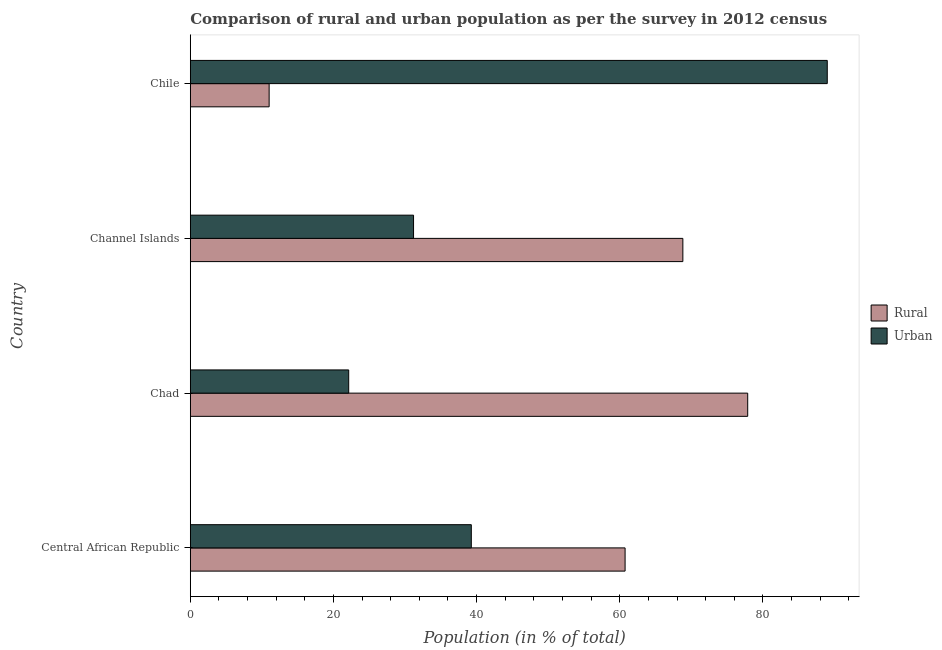How many groups of bars are there?
Your answer should be compact. 4. Are the number of bars on each tick of the Y-axis equal?
Your answer should be very brief. Yes. How many bars are there on the 2nd tick from the bottom?
Your answer should be very brief. 2. What is the label of the 2nd group of bars from the top?
Offer a terse response. Channel Islands. What is the rural population in Chad?
Give a very brief answer. 77.87. Across all countries, what is the maximum urban population?
Make the answer very short. 88.99. Across all countries, what is the minimum urban population?
Your answer should be compact. 22.13. In which country was the urban population maximum?
Your answer should be compact. Chile. In which country was the urban population minimum?
Give a very brief answer. Chad. What is the total urban population in the graph?
Ensure brevity in your answer.  181.56. What is the difference between the urban population in Central African Republic and that in Channel Islands?
Ensure brevity in your answer.  8.07. What is the difference between the rural population in Central African Republic and the urban population in Chile?
Keep it short and to the point. -28.24. What is the average urban population per country?
Provide a short and direct response. 45.39. What is the difference between the rural population and urban population in Central African Republic?
Give a very brief answer. 21.48. In how many countries, is the rural population greater than 60 %?
Give a very brief answer. 3. What is the ratio of the rural population in Central African Republic to that in Chile?
Your answer should be compact. 5.51. Is the urban population in Chad less than that in Chile?
Offer a terse response. Yes. Is the difference between the rural population in Central African Republic and Channel Islands greater than the difference between the urban population in Central African Republic and Channel Islands?
Ensure brevity in your answer.  No. What is the difference between the highest and the second highest urban population?
Offer a very short reply. 49.73. What is the difference between the highest and the lowest rural population?
Provide a succinct answer. 66.86. What does the 2nd bar from the top in Chile represents?
Make the answer very short. Rural. What does the 2nd bar from the bottom in Central African Republic represents?
Offer a terse response. Urban. How many bars are there?
Provide a short and direct response. 8. Does the graph contain any zero values?
Provide a succinct answer. No. How many legend labels are there?
Provide a succinct answer. 2. What is the title of the graph?
Your answer should be very brief. Comparison of rural and urban population as per the survey in 2012 census. What is the label or title of the X-axis?
Keep it short and to the point. Population (in % of total). What is the Population (in % of total) in Rural in Central African Republic?
Provide a short and direct response. 60.74. What is the Population (in % of total) of Urban in Central African Republic?
Offer a very short reply. 39.26. What is the Population (in % of total) in Rural in Chad?
Your response must be concise. 77.87. What is the Population (in % of total) of Urban in Chad?
Provide a succinct answer. 22.13. What is the Population (in % of total) in Rural in Channel Islands?
Provide a short and direct response. 68.81. What is the Population (in % of total) of Urban in Channel Islands?
Provide a succinct answer. 31.19. What is the Population (in % of total) of Rural in Chile?
Make the answer very short. 11.01. What is the Population (in % of total) in Urban in Chile?
Your answer should be compact. 88.99. Across all countries, what is the maximum Population (in % of total) in Rural?
Provide a succinct answer. 77.87. Across all countries, what is the maximum Population (in % of total) of Urban?
Your answer should be compact. 88.99. Across all countries, what is the minimum Population (in % of total) in Rural?
Your answer should be compact. 11.01. Across all countries, what is the minimum Population (in % of total) of Urban?
Make the answer very short. 22.13. What is the total Population (in % of total) of Rural in the graph?
Make the answer very short. 218.44. What is the total Population (in % of total) of Urban in the graph?
Provide a succinct answer. 181.56. What is the difference between the Population (in % of total) in Rural in Central African Republic and that in Chad?
Offer a terse response. -17.13. What is the difference between the Population (in % of total) of Urban in Central African Republic and that in Chad?
Make the answer very short. 17.13. What is the difference between the Population (in % of total) in Rural in Central African Republic and that in Channel Islands?
Offer a very short reply. -8.07. What is the difference between the Population (in % of total) in Urban in Central African Republic and that in Channel Islands?
Ensure brevity in your answer.  8.07. What is the difference between the Population (in % of total) of Rural in Central African Republic and that in Chile?
Give a very brief answer. 49.73. What is the difference between the Population (in % of total) in Urban in Central African Republic and that in Chile?
Provide a short and direct response. -49.73. What is the difference between the Population (in % of total) in Rural in Chad and that in Channel Islands?
Your answer should be very brief. 9.06. What is the difference between the Population (in % of total) of Urban in Chad and that in Channel Islands?
Your response must be concise. -9.06. What is the difference between the Population (in % of total) of Rural in Chad and that in Chile?
Ensure brevity in your answer.  66.86. What is the difference between the Population (in % of total) of Urban in Chad and that in Chile?
Your answer should be compact. -66.86. What is the difference between the Population (in % of total) of Rural in Channel Islands and that in Chile?
Keep it short and to the point. 57.8. What is the difference between the Population (in % of total) of Urban in Channel Islands and that in Chile?
Make the answer very short. -57.8. What is the difference between the Population (in % of total) of Rural in Central African Republic and the Population (in % of total) of Urban in Chad?
Your answer should be compact. 38.61. What is the difference between the Population (in % of total) of Rural in Central African Republic and the Population (in % of total) of Urban in Channel Islands?
Your answer should be compact. 29.55. What is the difference between the Population (in % of total) of Rural in Central African Republic and the Population (in % of total) of Urban in Chile?
Provide a succinct answer. -28.24. What is the difference between the Population (in % of total) in Rural in Chad and the Population (in % of total) in Urban in Channel Islands?
Keep it short and to the point. 46.68. What is the difference between the Population (in % of total) in Rural in Chad and the Population (in % of total) in Urban in Chile?
Provide a short and direct response. -11.12. What is the difference between the Population (in % of total) in Rural in Channel Islands and the Population (in % of total) in Urban in Chile?
Your response must be concise. -20.18. What is the average Population (in % of total) of Rural per country?
Make the answer very short. 54.61. What is the average Population (in % of total) in Urban per country?
Your response must be concise. 45.39. What is the difference between the Population (in % of total) of Rural and Population (in % of total) of Urban in Central African Republic?
Provide a succinct answer. 21.48. What is the difference between the Population (in % of total) of Rural and Population (in % of total) of Urban in Chad?
Provide a short and direct response. 55.74. What is the difference between the Population (in % of total) of Rural and Population (in % of total) of Urban in Channel Islands?
Provide a succinct answer. 37.62. What is the difference between the Population (in % of total) in Rural and Population (in % of total) in Urban in Chile?
Make the answer very short. -77.97. What is the ratio of the Population (in % of total) in Rural in Central African Republic to that in Chad?
Your answer should be very brief. 0.78. What is the ratio of the Population (in % of total) of Urban in Central African Republic to that in Chad?
Ensure brevity in your answer.  1.77. What is the ratio of the Population (in % of total) in Rural in Central African Republic to that in Channel Islands?
Provide a succinct answer. 0.88. What is the ratio of the Population (in % of total) in Urban in Central African Republic to that in Channel Islands?
Ensure brevity in your answer.  1.26. What is the ratio of the Population (in % of total) of Rural in Central African Republic to that in Chile?
Give a very brief answer. 5.51. What is the ratio of the Population (in % of total) in Urban in Central African Republic to that in Chile?
Make the answer very short. 0.44. What is the ratio of the Population (in % of total) in Rural in Chad to that in Channel Islands?
Offer a terse response. 1.13. What is the ratio of the Population (in % of total) in Urban in Chad to that in Channel Islands?
Provide a short and direct response. 0.71. What is the ratio of the Population (in % of total) of Rural in Chad to that in Chile?
Your response must be concise. 7.07. What is the ratio of the Population (in % of total) of Urban in Chad to that in Chile?
Make the answer very short. 0.25. What is the ratio of the Population (in % of total) in Rural in Channel Islands to that in Chile?
Your answer should be compact. 6.25. What is the ratio of the Population (in % of total) in Urban in Channel Islands to that in Chile?
Offer a very short reply. 0.35. What is the difference between the highest and the second highest Population (in % of total) in Rural?
Your response must be concise. 9.06. What is the difference between the highest and the second highest Population (in % of total) in Urban?
Offer a terse response. 49.73. What is the difference between the highest and the lowest Population (in % of total) of Rural?
Your answer should be compact. 66.86. What is the difference between the highest and the lowest Population (in % of total) in Urban?
Ensure brevity in your answer.  66.86. 